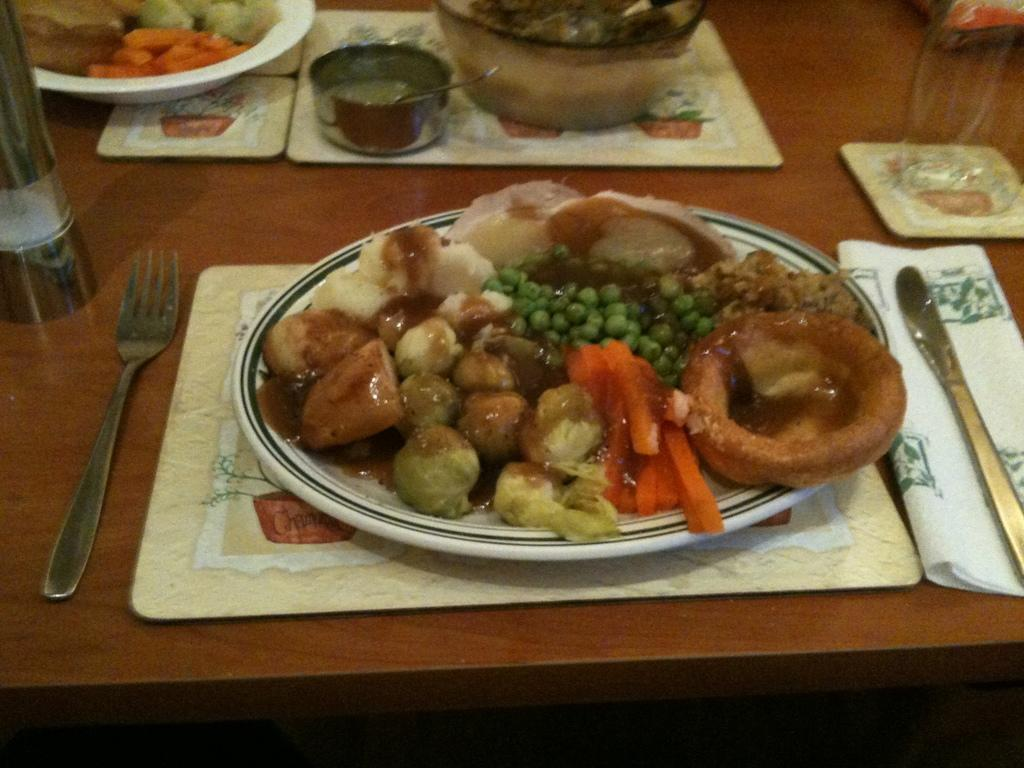What type of furniture is present in the image? There is a table in the image. What items can be seen on the table? There are cards, a plate, bowls, a glass, a bottle, a fork, and a knife on the table. What else is present on the table besides utensils and tableware? There is food on the table. Can you see any dirt on the table in the image? There is no mention of dirt in the image, so it cannot be determined if any is present. 